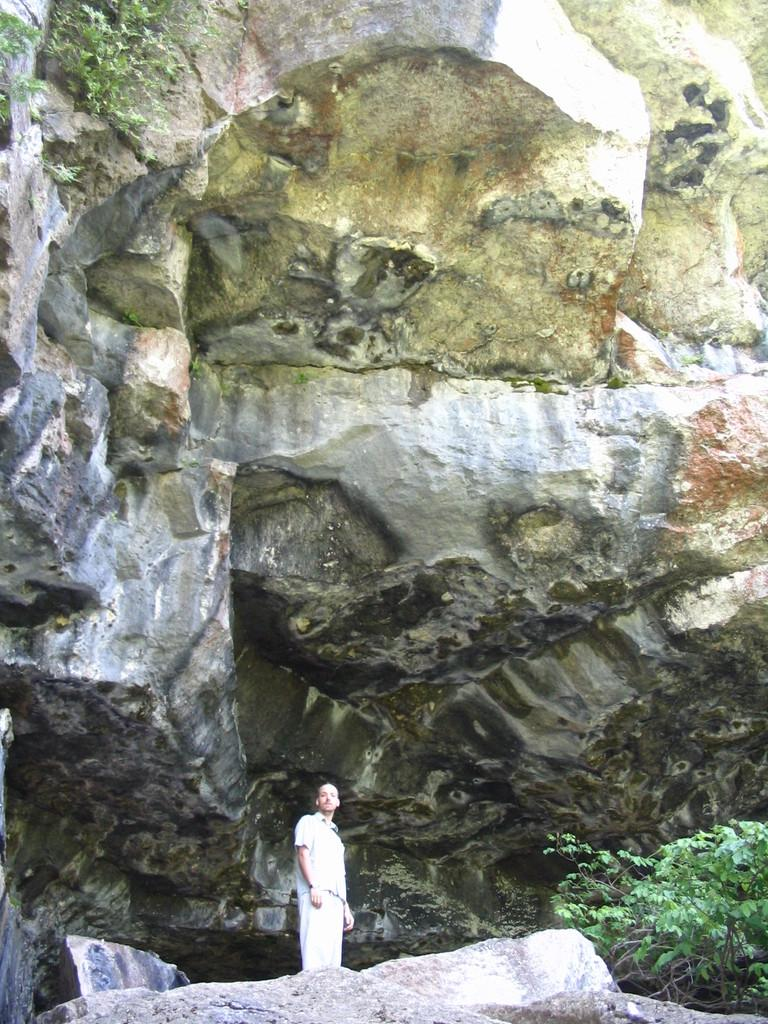What is the main subject of the image? There is a person standing on rocks at the bottom of the image. What can be seen on the right side of the image? There are plants on the right side of the image. What is present at the top of the image? There are rocks and plants at the top of the image. Can you tell me who the person is fighting with in the image? There is no fight or any other person present in the image; it only shows a person standing on rocks. 